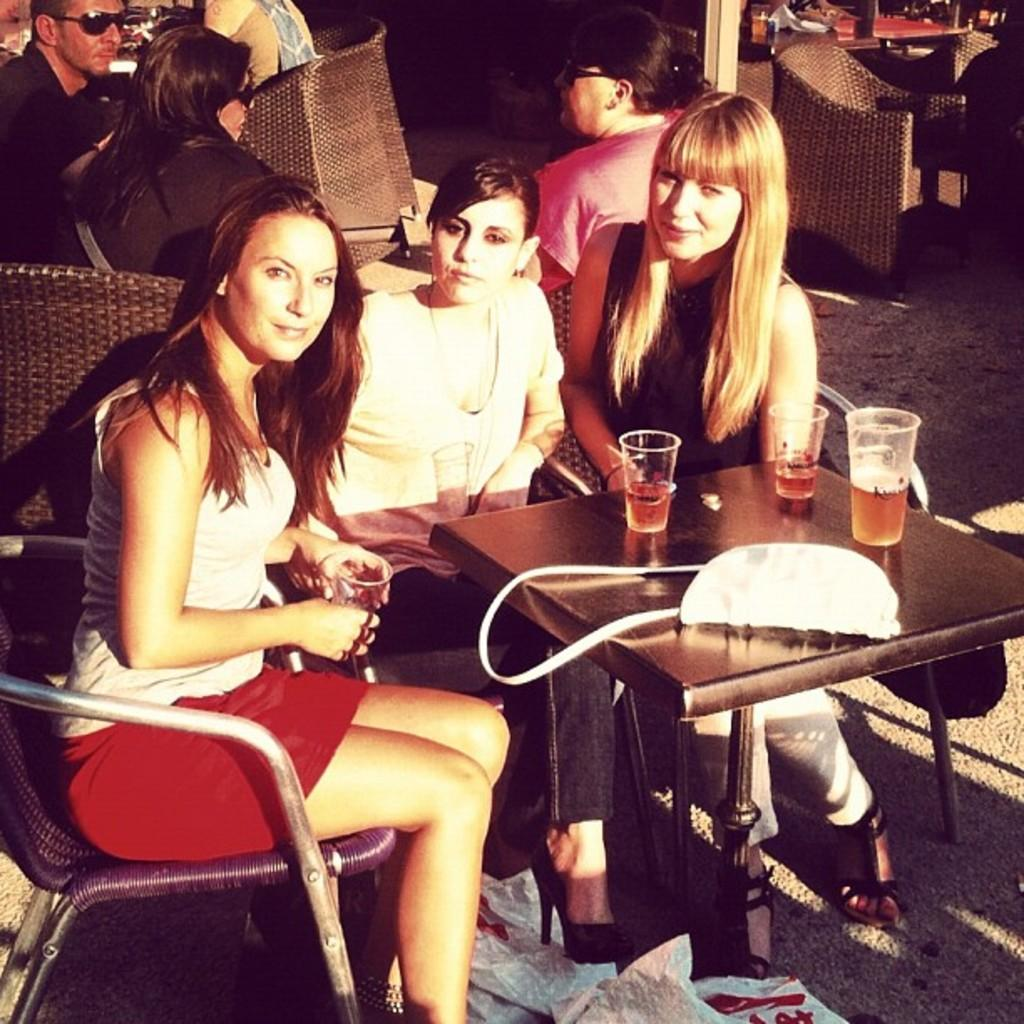What is happening in the image involving a group of people? There is a group of people in the image, and they are seated on chairs. What objects are present on the table in front of the people? There are glasses on a table in front of the people, and there is also a bag on the table. What type of cars can be seen in the yard in the image? There is no yard or cars present in the image. What kind of vessel is being used by the people in the image? The image does not show any vessels being used by the people; they are simply seated on chairs with glasses and a bag on the table. 